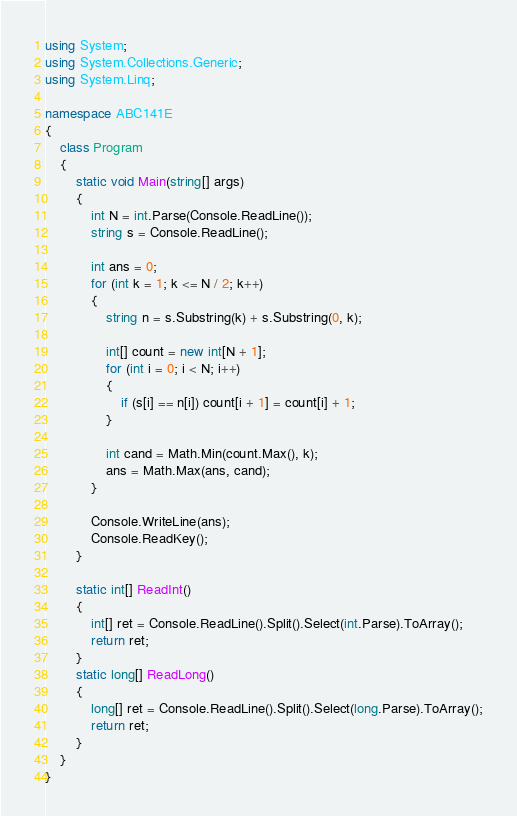Convert code to text. <code><loc_0><loc_0><loc_500><loc_500><_C#_>using System;
using System.Collections.Generic;
using System.Linq;

namespace ABC141E
{
    class Program
    {
        static void Main(string[] args)
        {
            int N = int.Parse(Console.ReadLine());
            string s = Console.ReadLine();

            int ans = 0;
            for (int k = 1; k <= N / 2; k++)
            {
                string n = s.Substring(k) + s.Substring(0, k);

                int[] count = new int[N + 1];
                for (int i = 0; i < N; i++)
                {
                    if (s[i] == n[i]) count[i + 1] = count[i] + 1;
                }

                int cand = Math.Min(count.Max(), k);
                ans = Math.Max(ans, cand);
            }

            Console.WriteLine(ans);
            Console.ReadKey();
        }

        static int[] ReadInt()
        {
            int[] ret = Console.ReadLine().Split().Select(int.Parse).ToArray();
            return ret;
        }
        static long[] ReadLong()
        {
            long[] ret = Console.ReadLine().Split().Select(long.Parse).ToArray();
            return ret;
        }
    }
}
</code> 